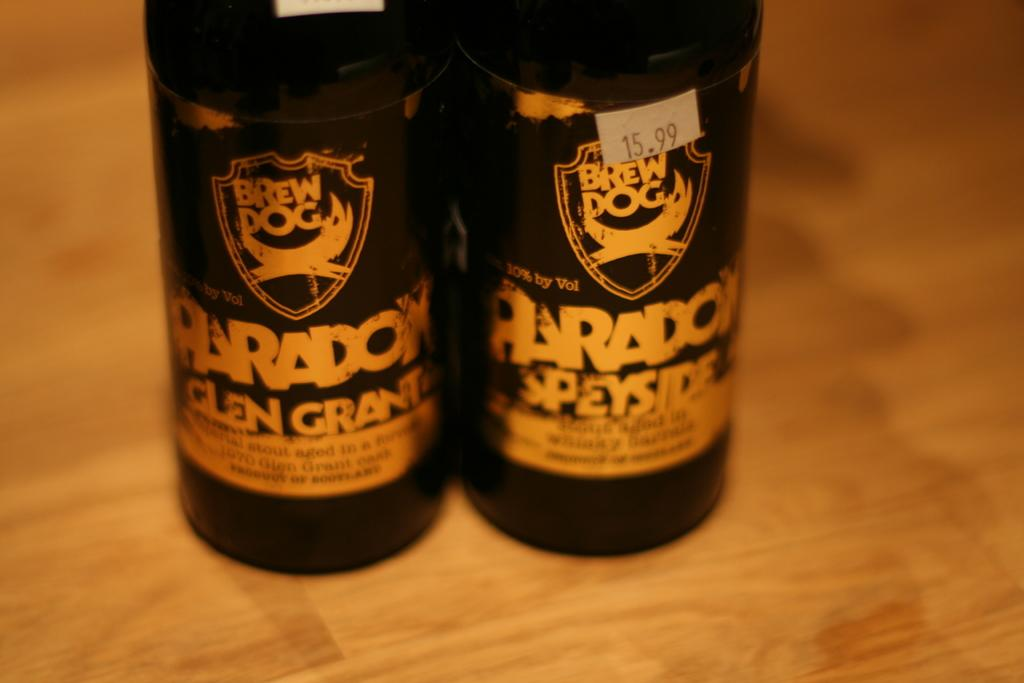<image>
Share a concise interpretation of the image provided. Two bottles of Brew Dog Paradox beer with gold labels. 